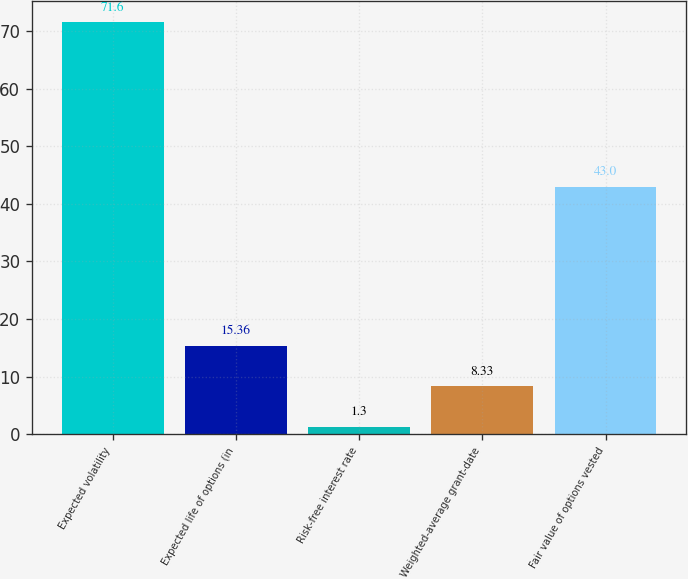<chart> <loc_0><loc_0><loc_500><loc_500><bar_chart><fcel>Expected volatility<fcel>Expected life of options (in<fcel>Risk-free interest rate<fcel>Weighted-average grant-date<fcel>Fair value of options vested<nl><fcel>71.6<fcel>15.36<fcel>1.3<fcel>8.33<fcel>43<nl></chart> 